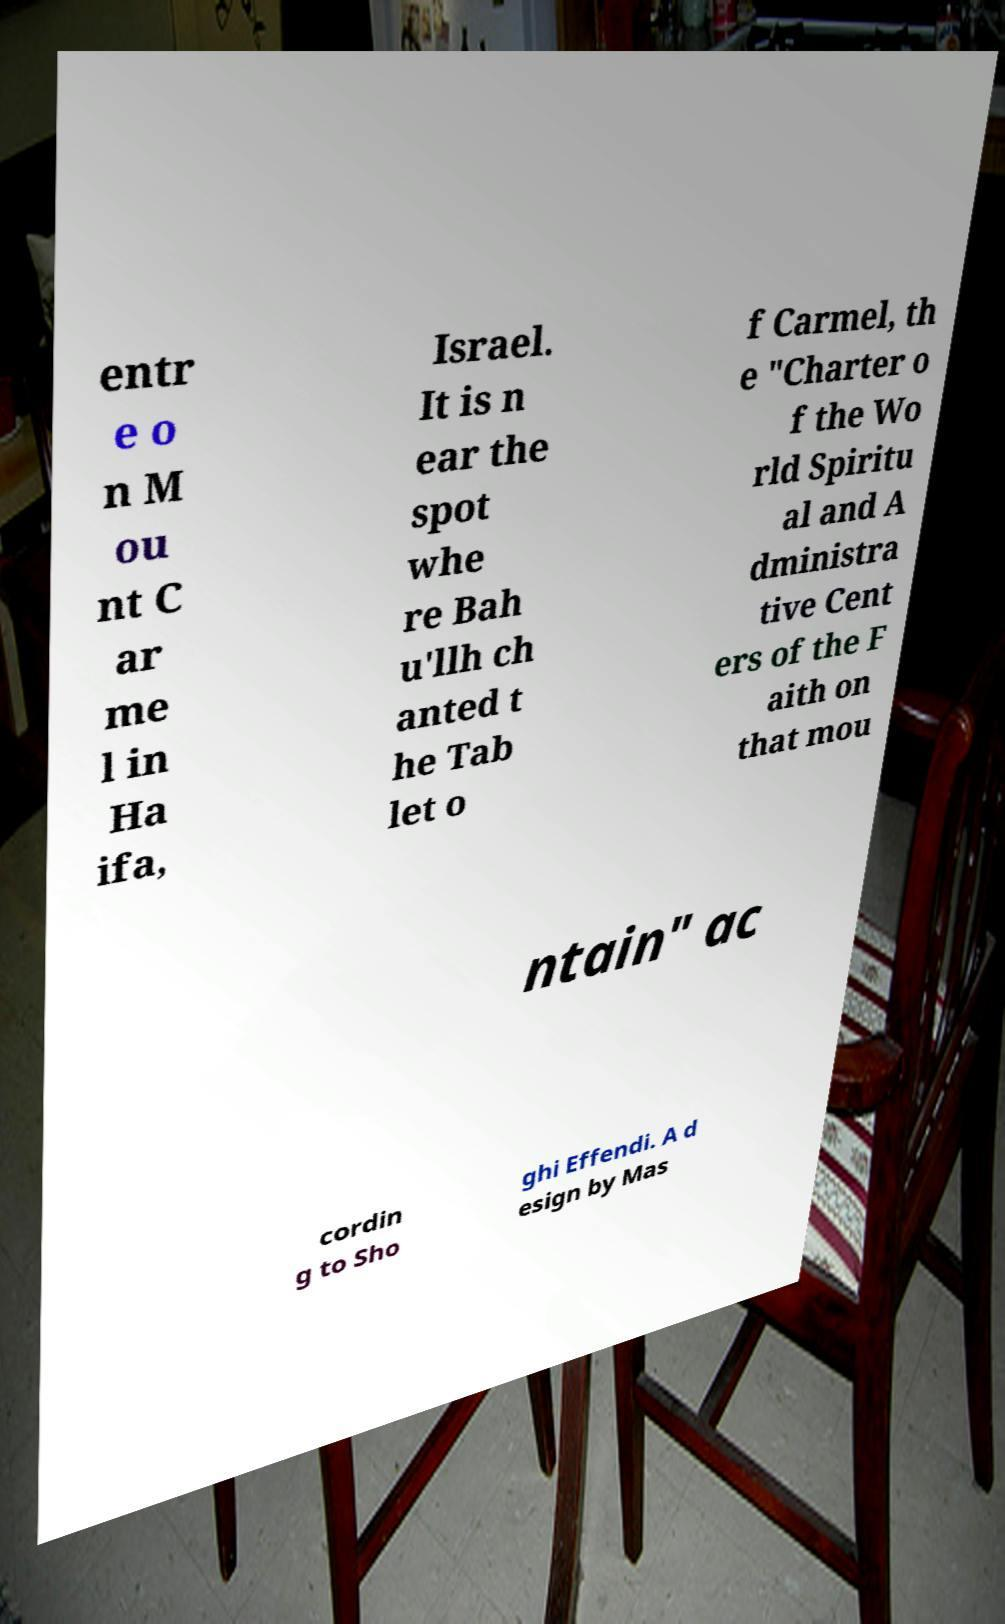What messages or text are displayed in this image? I need them in a readable, typed format. entr e o n M ou nt C ar me l in Ha ifa, Israel. It is n ear the spot whe re Bah u'llh ch anted t he Tab let o f Carmel, th e "Charter o f the Wo rld Spiritu al and A dministra tive Cent ers of the F aith on that mou ntain" ac cordin g to Sho ghi Effendi. A d esign by Mas 